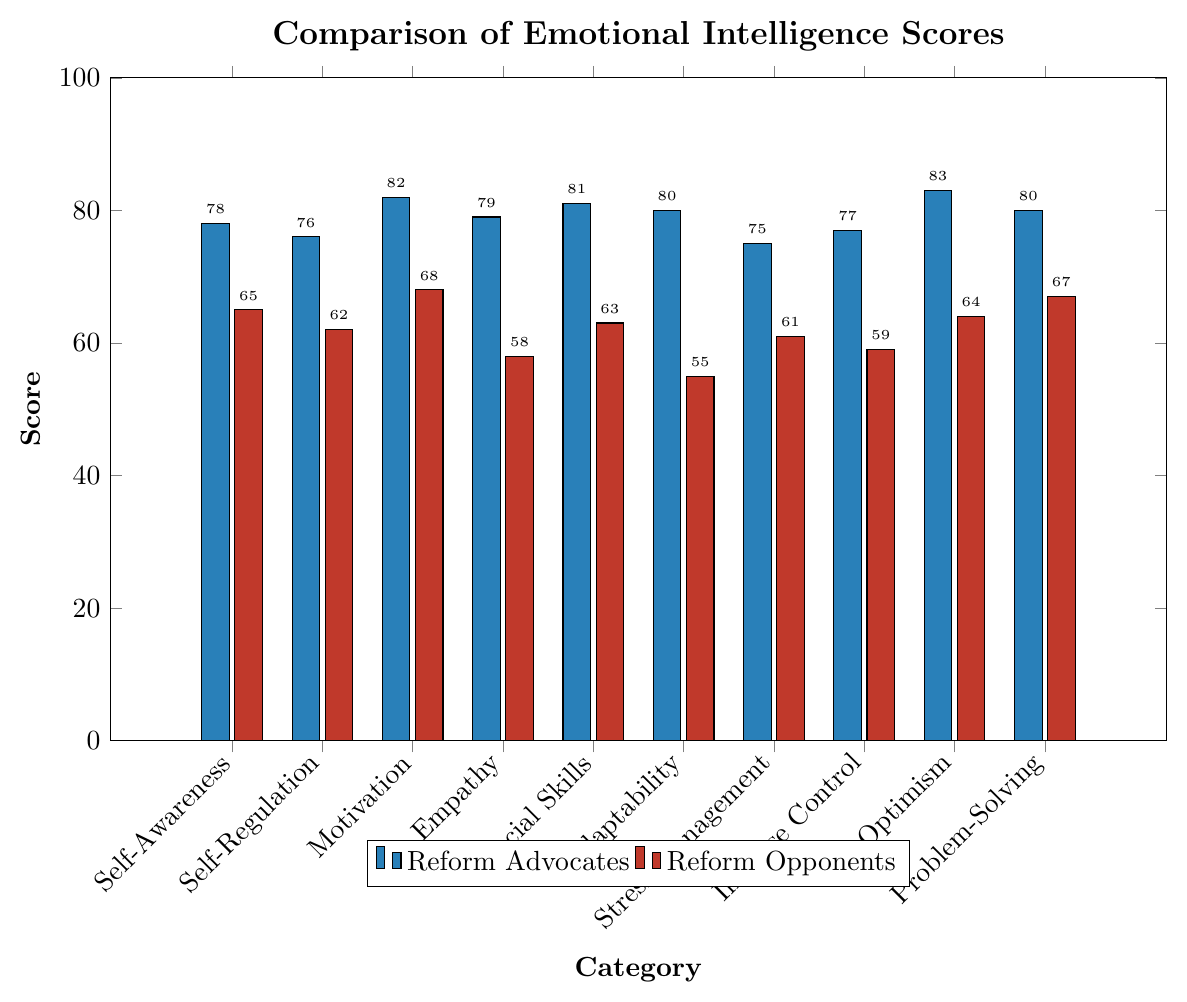What category has the largest difference in scores between reform advocates and opponents? To find the category with the largest difference, calculate the absolute differences between the scores of each category for reform advocates and opponents. Empathy has the values of 79 and 58, resulting in the largest difference of 21.
Answer: Empathy Which group scores higher in 'Self-Regulation'? Refer to the bars corresponding to 'Self-Regulation' for both groups. Reform advocates score 76, while reform opponents score 62. Reform advocates score higher.
Answer: Reform advocates How many categories have reform opponents scoring below 60? Refer to each bar representing the reform opponents and count the number of bars whose scores are below 60. The categories 'Empathy', 'Adaptability', 'Impulse Control', and 'Social Skills' are below 60, making it 4 categories in total.
Answer: 4 What is the average score for reform advocates in the 'Self-Awareness' and 'Motivation' categories? Add the scores of reform advocates for 'Self-Awareness' and 'Motivation', then divide by 2. (78 + 82) / 2 = 80.
Answer: 80 Which category shows the closest scores between reform advocates and reform opponents? Calculate the absolute differences between the scores of the two groups for each category and find the smallest difference. 'Stress Management' has the closest scores of 75 and 61, resulting in a difference of 14.
Answer: Stress Management Are there any categories where both groups score above 70? Check the scores for each category to see if both groups have scores above 70. 'Self-Awareness', 'Motivation', 'Social Skills', 'Adaptability', 'Optimism', and 'Problem-Solving' categories show this. However, none meet the criteria for both groups.
Answer: No What is the total score for reform advocates across all categories? Sum the scores of reform advocates for all categories: 78 + 76 + 82 + 79 + 81 + 80 + 75 + 77 + 83 + 80 = 791.
Answer: 791 Which group scores higher in 'Stress Management', and by how much? Refer to the bars corresponding to 'Stress Management' for both groups. Reform advocates have a score of 75, while reform opponents have a score of 61. The difference is 75 - 61 = 14.
Answer: Reform advocates by 14 What is the difference between the highest and lowest scores for reform opponents? Identify the highest and lowest scores among reform opponents. 'Optimism' has the highest score of 64, and 'Adaptability' has the lowest score of 55. The difference is 64 - 55 = 9.
Answer: 9 